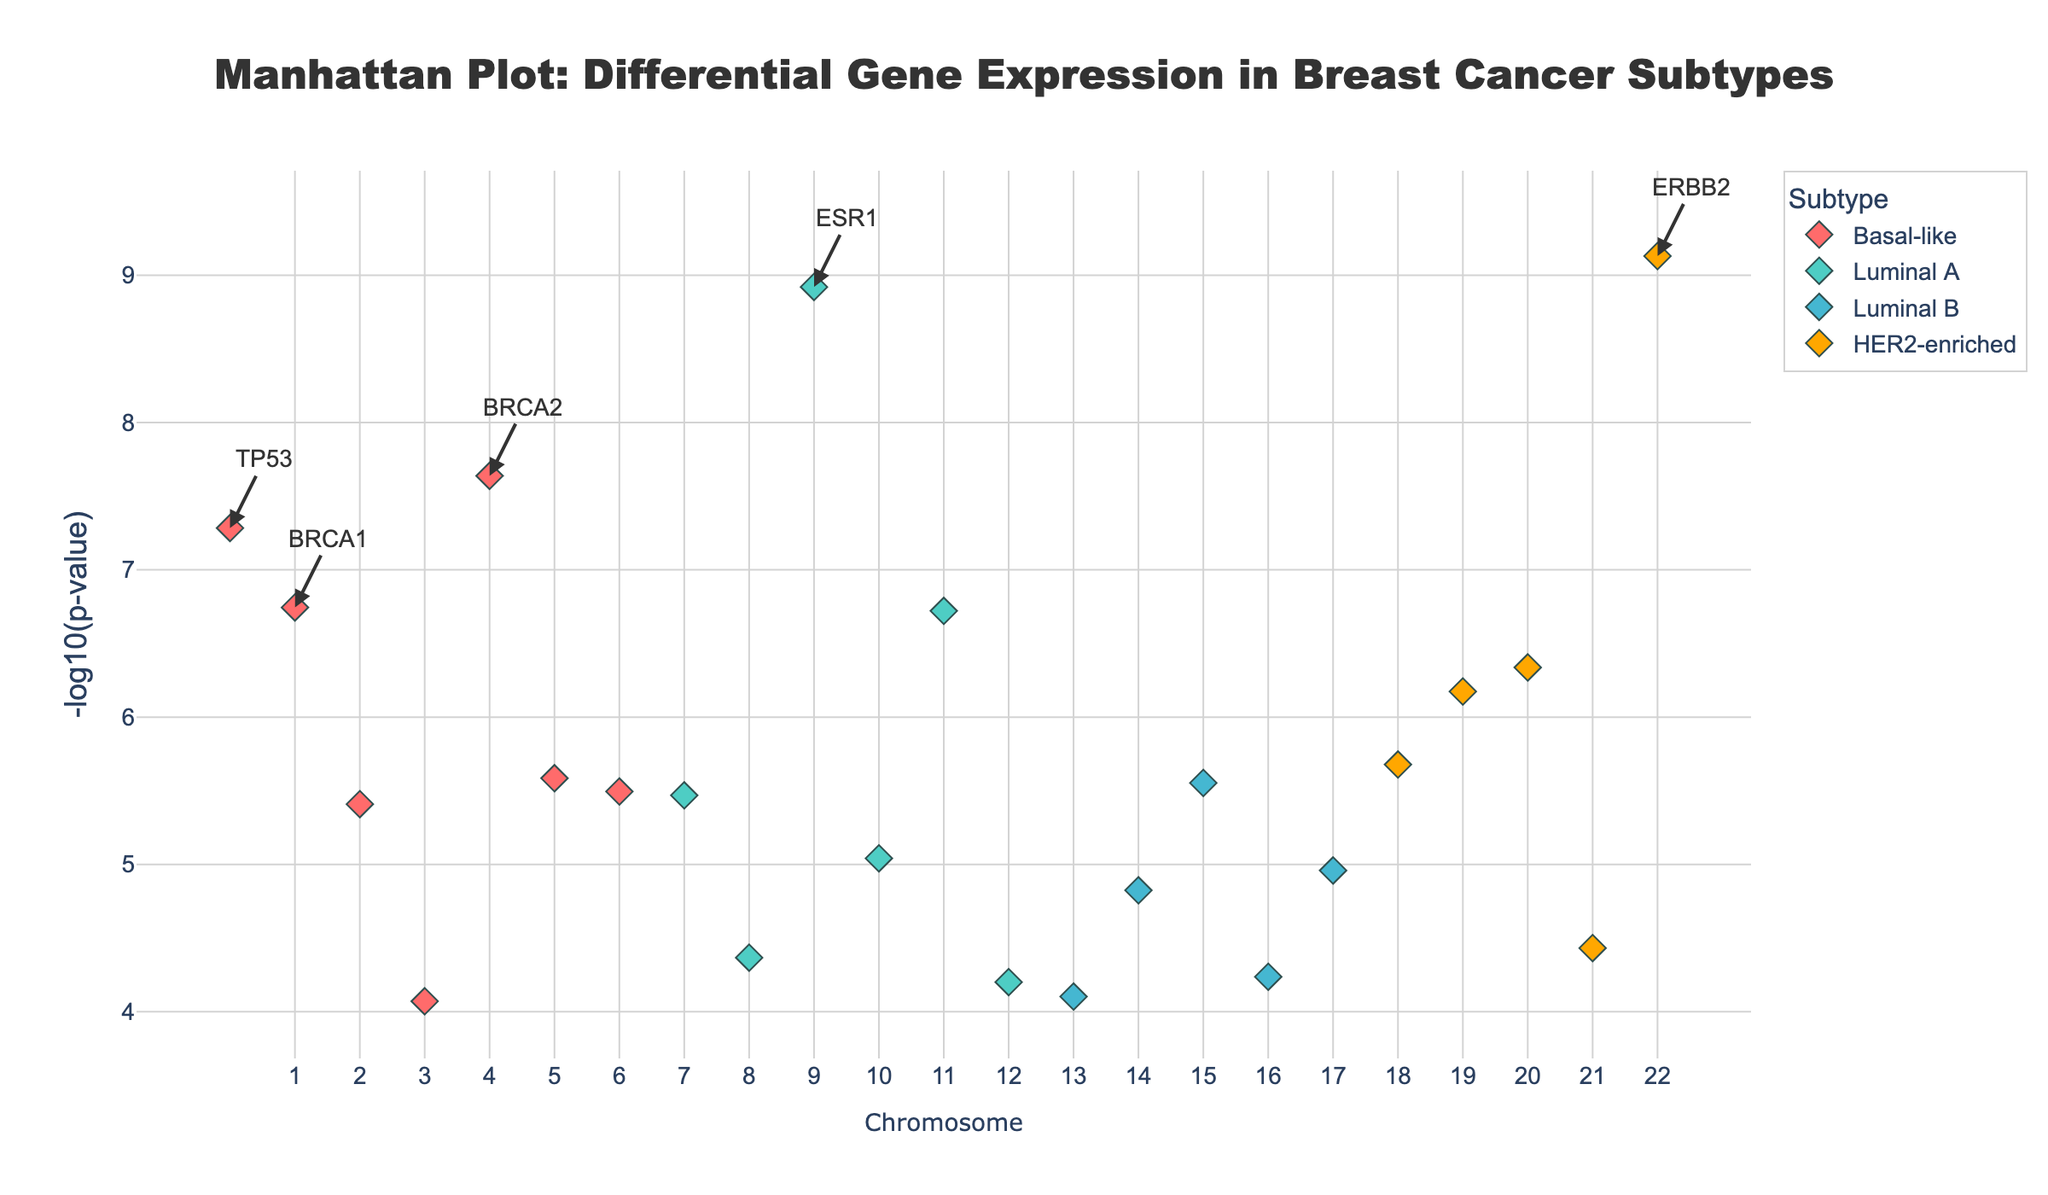What does the title of the Manhattan plot indicate? The title "Manhattan Plot: Differential Gene Expression in Breast Cancer Subtypes" suggests that the plot displays the results of differential gene expression analysis across different breast cancer subtypes on a genome-wide scale.
Answer: Differential Gene Expression in Breast Cancer Subtypes What is the x-axis in this plot? The x-axis represents the different chromosomes, with each chromosome labeled consecutively. Data points are distributed across these chromosomes.
Answer: Chromosome What is represented on the y-axis of this plot? The y-axis represents the -log10 of the p-values, which indicates the statistical significance of differential gene expression; higher values signify more significant genes.
Answer: -log10(p-value) Which subtype has the highest number of highlighted genes? By counting the number of markers with different colors representing each subtype, we see that the 'Basal-like' subtype has the highest number of highlighted genes.
Answer: Basal-like Which gene is the most significantly differentially expressed in this plot? The gene annotation labels added to the top significant genes show that 'ERBB2' has the highest -log10(p-value), indicating it is the most significantly differentially expressed gene.
Answer: ERBB2 How do the genes 'TP53' and 'BRCA2' compare in terms of their significance? Both genes are significantly different, but 'BRCA2' has a higher -log10(p-value) than 'TP53', indicating 'BRCA2' is more statistically significant in differential expression.
Answer: BRCA2 is more significant than TP53 For the Luminal A subtype, which gene has the lowest -log10(p-value) value? For Luminal A, we look at the turquoise-colored points. Based on the hover template information, 'SRC' has the lowest -log10(p-value) value among the Luminal A genes.
Answer: SRC Which gene is most significant within the HER2-enriched subtype? The bright orange markers represent HER2-enriched subtypes. According to the gene annotations and plot, 'ERBB2' is the most significant gene within this subtype.
Answer: ERBB2 How many genes have a -log10(p-value) greater than 7? By scrutinizing the plot, we identify the genes with points plotted above the 7 mark on the y-axis. There are 4 such genes: TP53, BRCA1, BRCA2, and ERBB2.
Answer: 4 Is the ALK gene more significant in Luminal A or Luminal B subtype? According to the plot, 'ALK' is depicted in turquoise which denotes it belongs to the Luminal A subtype. Therefore, 'ALK' is plotted with a significance level corresponding to Luminal A.
Answer: Luminal A 